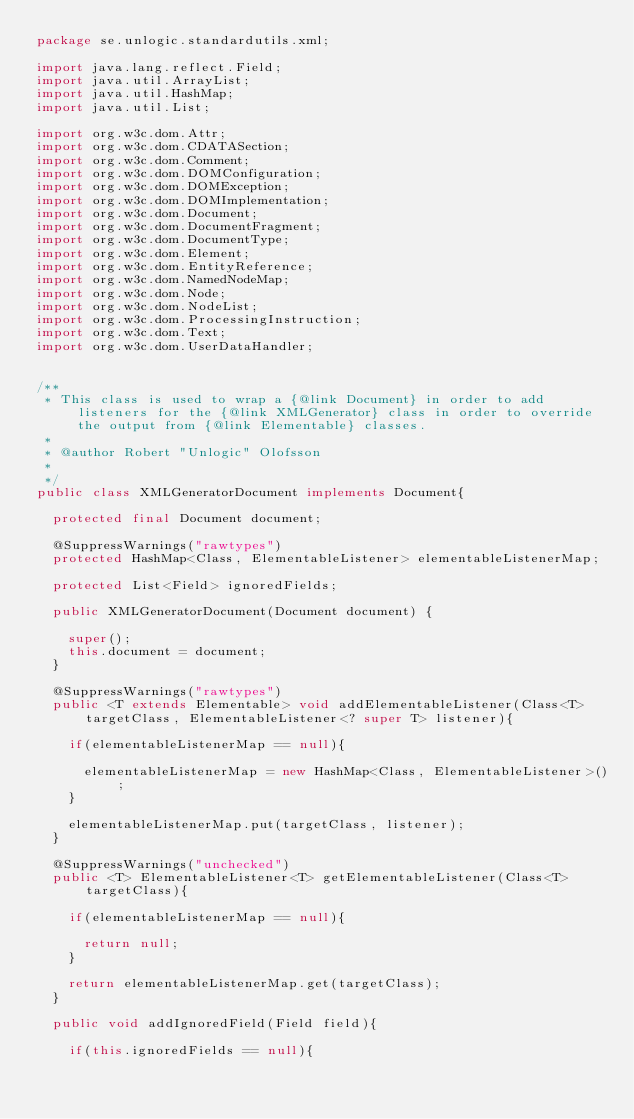Convert code to text. <code><loc_0><loc_0><loc_500><loc_500><_Java_>package se.unlogic.standardutils.xml;

import java.lang.reflect.Field;
import java.util.ArrayList;
import java.util.HashMap;
import java.util.List;

import org.w3c.dom.Attr;
import org.w3c.dom.CDATASection;
import org.w3c.dom.Comment;
import org.w3c.dom.DOMConfiguration;
import org.w3c.dom.DOMException;
import org.w3c.dom.DOMImplementation;
import org.w3c.dom.Document;
import org.w3c.dom.DocumentFragment;
import org.w3c.dom.DocumentType;
import org.w3c.dom.Element;
import org.w3c.dom.EntityReference;
import org.w3c.dom.NamedNodeMap;
import org.w3c.dom.Node;
import org.w3c.dom.NodeList;
import org.w3c.dom.ProcessingInstruction;
import org.w3c.dom.Text;
import org.w3c.dom.UserDataHandler;


/**
 * This class is used to wrap a {@link Document} in order to add listeners for the {@link XMLGenerator} class in order to override the output from {@link Elementable} classes. 
 * 
 * @author Robert "Unlogic" Olofsson
 *
 */
public class XMLGeneratorDocument implements Document{

	protected final Document document;
	
	@SuppressWarnings("rawtypes")
	protected HashMap<Class, ElementableListener> elementableListenerMap;
		
	protected List<Field> ignoredFields;
	
	public XMLGeneratorDocument(Document document) {

		super();
		this.document = document;
	}

	@SuppressWarnings("rawtypes")
	public <T extends Elementable> void addElementableListener(Class<T> targetClass, ElementableListener<? super T> listener){
		
		if(elementableListenerMap == null){
			
			elementableListenerMap = new HashMap<Class, ElementableListener>();
		}
		
		elementableListenerMap.put(targetClass, listener);
	}
	
	@SuppressWarnings("unchecked")
	public <T> ElementableListener<T> getElementableListener(Class<T> targetClass){
		
		if(elementableListenerMap == null){
			
			return null;
		}
		
		return elementableListenerMap.get(targetClass);
	}
	
	public void addIgnoredField(Field field){
		
		if(this.ignoredFields == null){
			</code> 